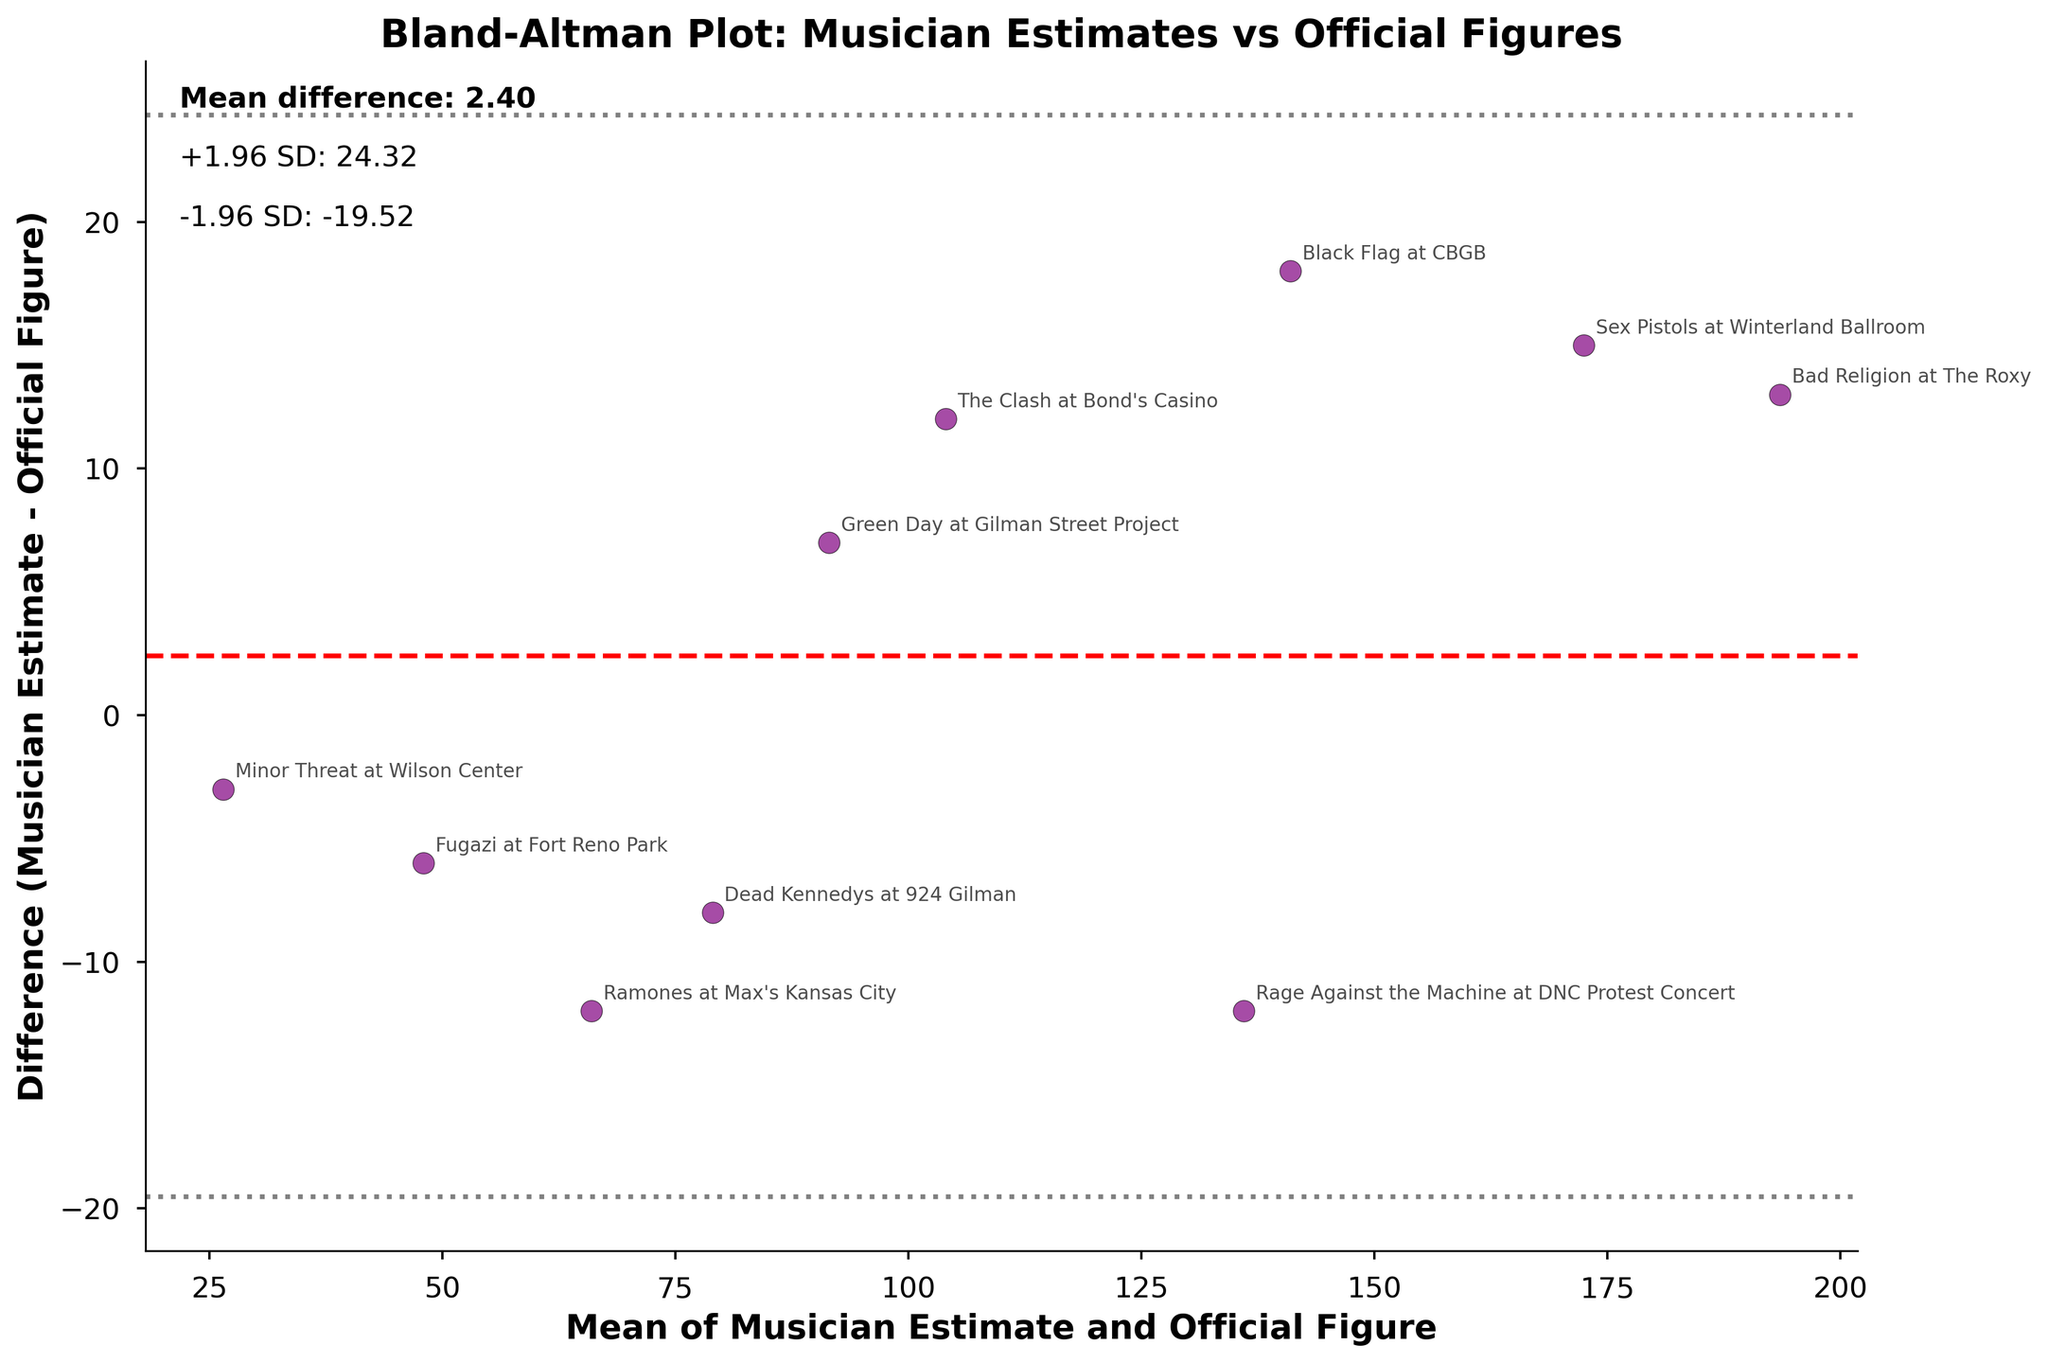What is the title of the plot? The title is located at the top of the plot, it clearly states the main comparison.
Answer: Bland-Altman Plot: Musician Estimates vs Official Figures What do the red dashed lines represent? The red dashed line is located around the middle of the plot; it indicates the mean difference between musician estimates and official figures.
Answer: Mean difference Which concert has the largest positive difference between musician estimate and official figure? By locating the data point with the highest value above zero on the vertical axis and checking the annotation.
Answer: Bad Religion at The Roxy What's the range of the mean of musician estimates and official figures? Identify the lowest and highest values on the horizontal axis to find the range.
Answer: 26.5 to 171 How many concerts have musician estimates that are higher than official figures? Count the number of points above the zero line on the vertical axis.
Answer: 6 Which data point is nearest to the mean difference line? Find the data point closest to the red dashed line on the vertical axis.
Answer: Green Day at Gilman Street Project What are the gray dotted lines representing? The gray dotted lines are parallel to the mean difference line and located approximately equal distances above and below it. They indicate ±1.96 standard deviations from the mean difference.
Answer: ±1.96 standard deviations What is the value of the upper limit of agreement? Add 1.96 times the standard deviation to the mean difference and look for this value on the plot next to the upper gray dotted line.
Answer: 22.62 How many concerts have higher official figures than musician estimates? Count the number of data points below the zero line on the vertical axis.
Answer: 4 Which concerts have their differences falling outside the limits of agreement? Identify data points that lie outside the range indicated by the gray dotted lines.
Answer: No concerts 